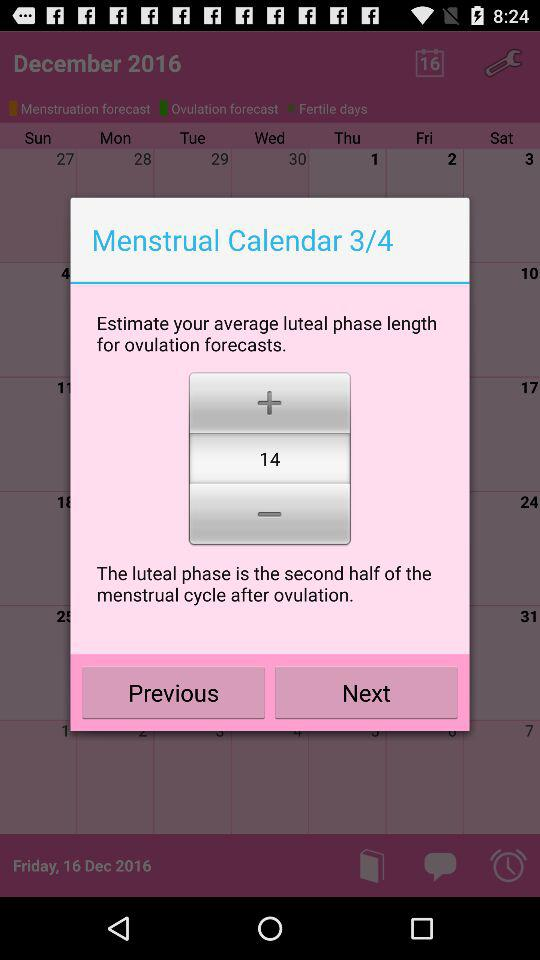What is the length of the luteal phase in days?
Answer the question using a single word or phrase. 14 